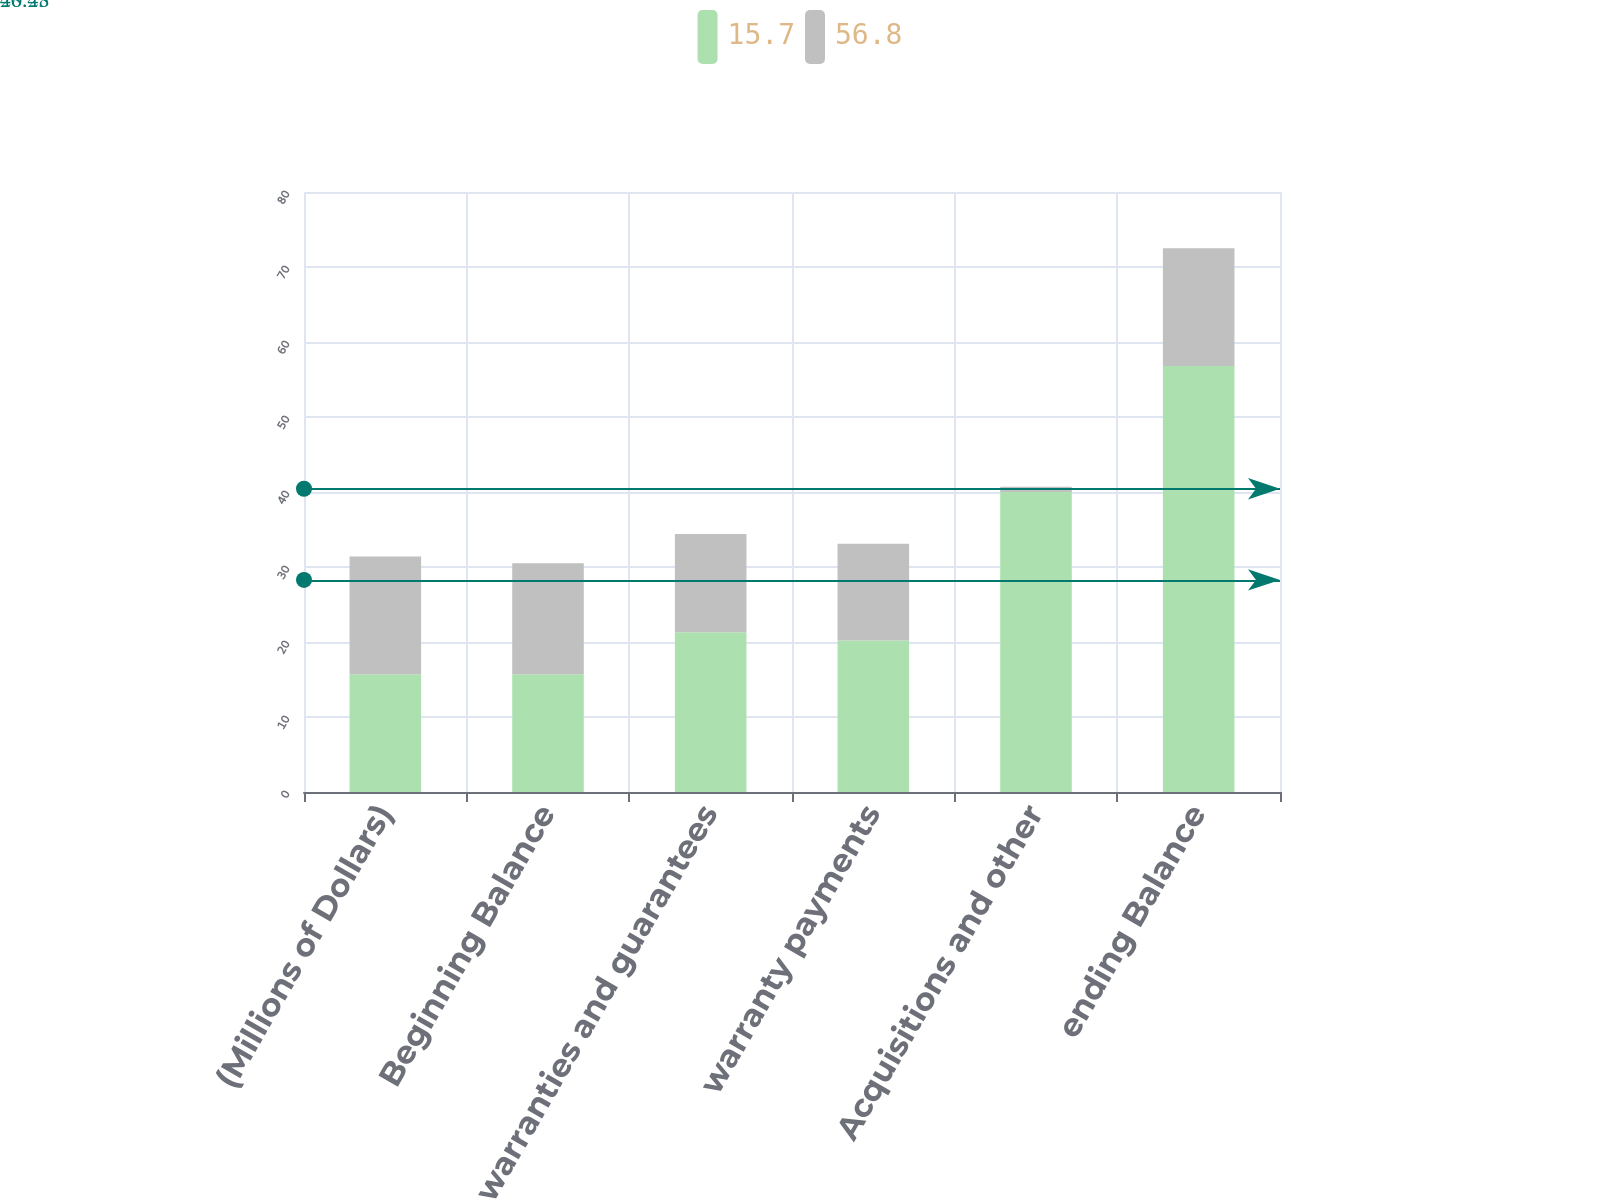Convert chart to OTSL. <chart><loc_0><loc_0><loc_500><loc_500><stacked_bar_chart><ecel><fcel>(Millions of Dollars)<fcel>Beginning Balance<fcel>warranties and guarantees<fcel>warranty payments<fcel>Acquisitions and other<fcel>ending Balance<nl><fcel>15.7<fcel>15.7<fcel>15.7<fcel>21.3<fcel>20.2<fcel>40<fcel>56.8<nl><fcel>56.8<fcel>15.7<fcel>14.8<fcel>13.1<fcel>12.9<fcel>0.7<fcel>15.7<nl></chart> 